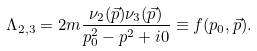Convert formula to latex. <formula><loc_0><loc_0><loc_500><loc_500>\Lambda _ { 2 , 3 } = 2 m \frac { \nu _ { 2 } ( \vec { p } ) \nu _ { 3 } ( \vec { p } ) } { p ^ { 2 } _ { 0 } - p ^ { 2 } + i 0 } \equiv f ( p _ { 0 } , \vec { p } ) .</formula> 